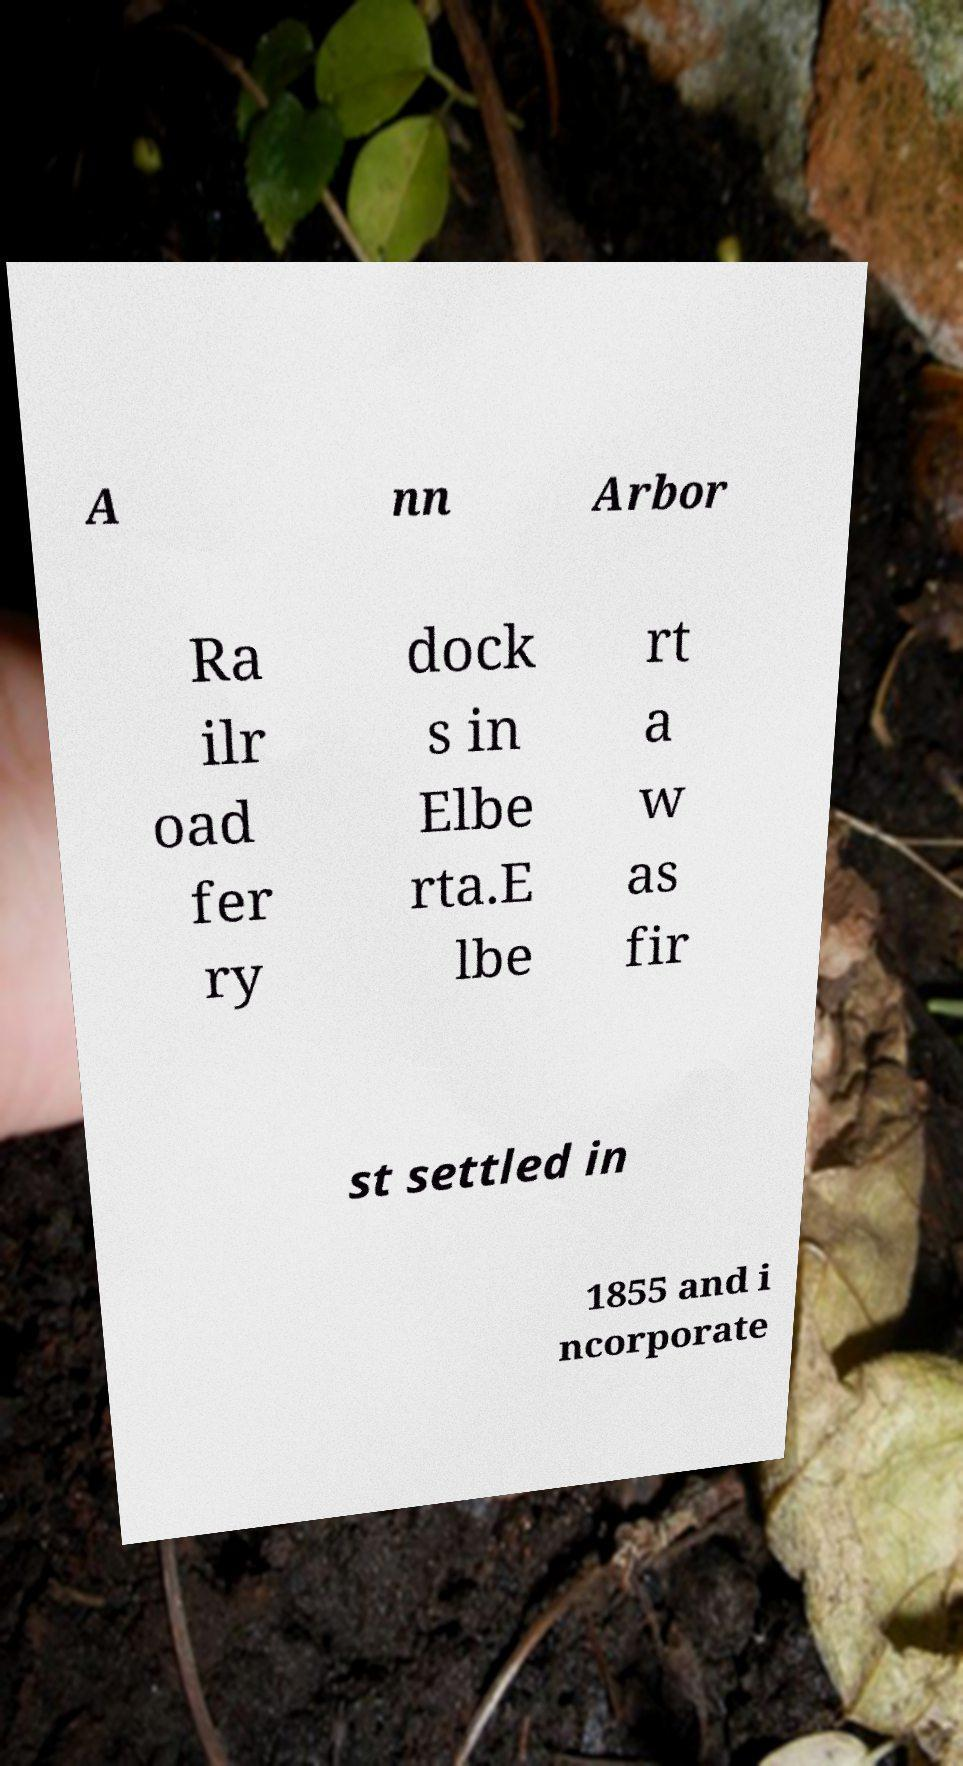Please read and relay the text visible in this image. What does it say? A nn Arbor Ra ilr oad fer ry dock s in Elbe rta.E lbe rt a w as fir st settled in 1855 and i ncorporate 